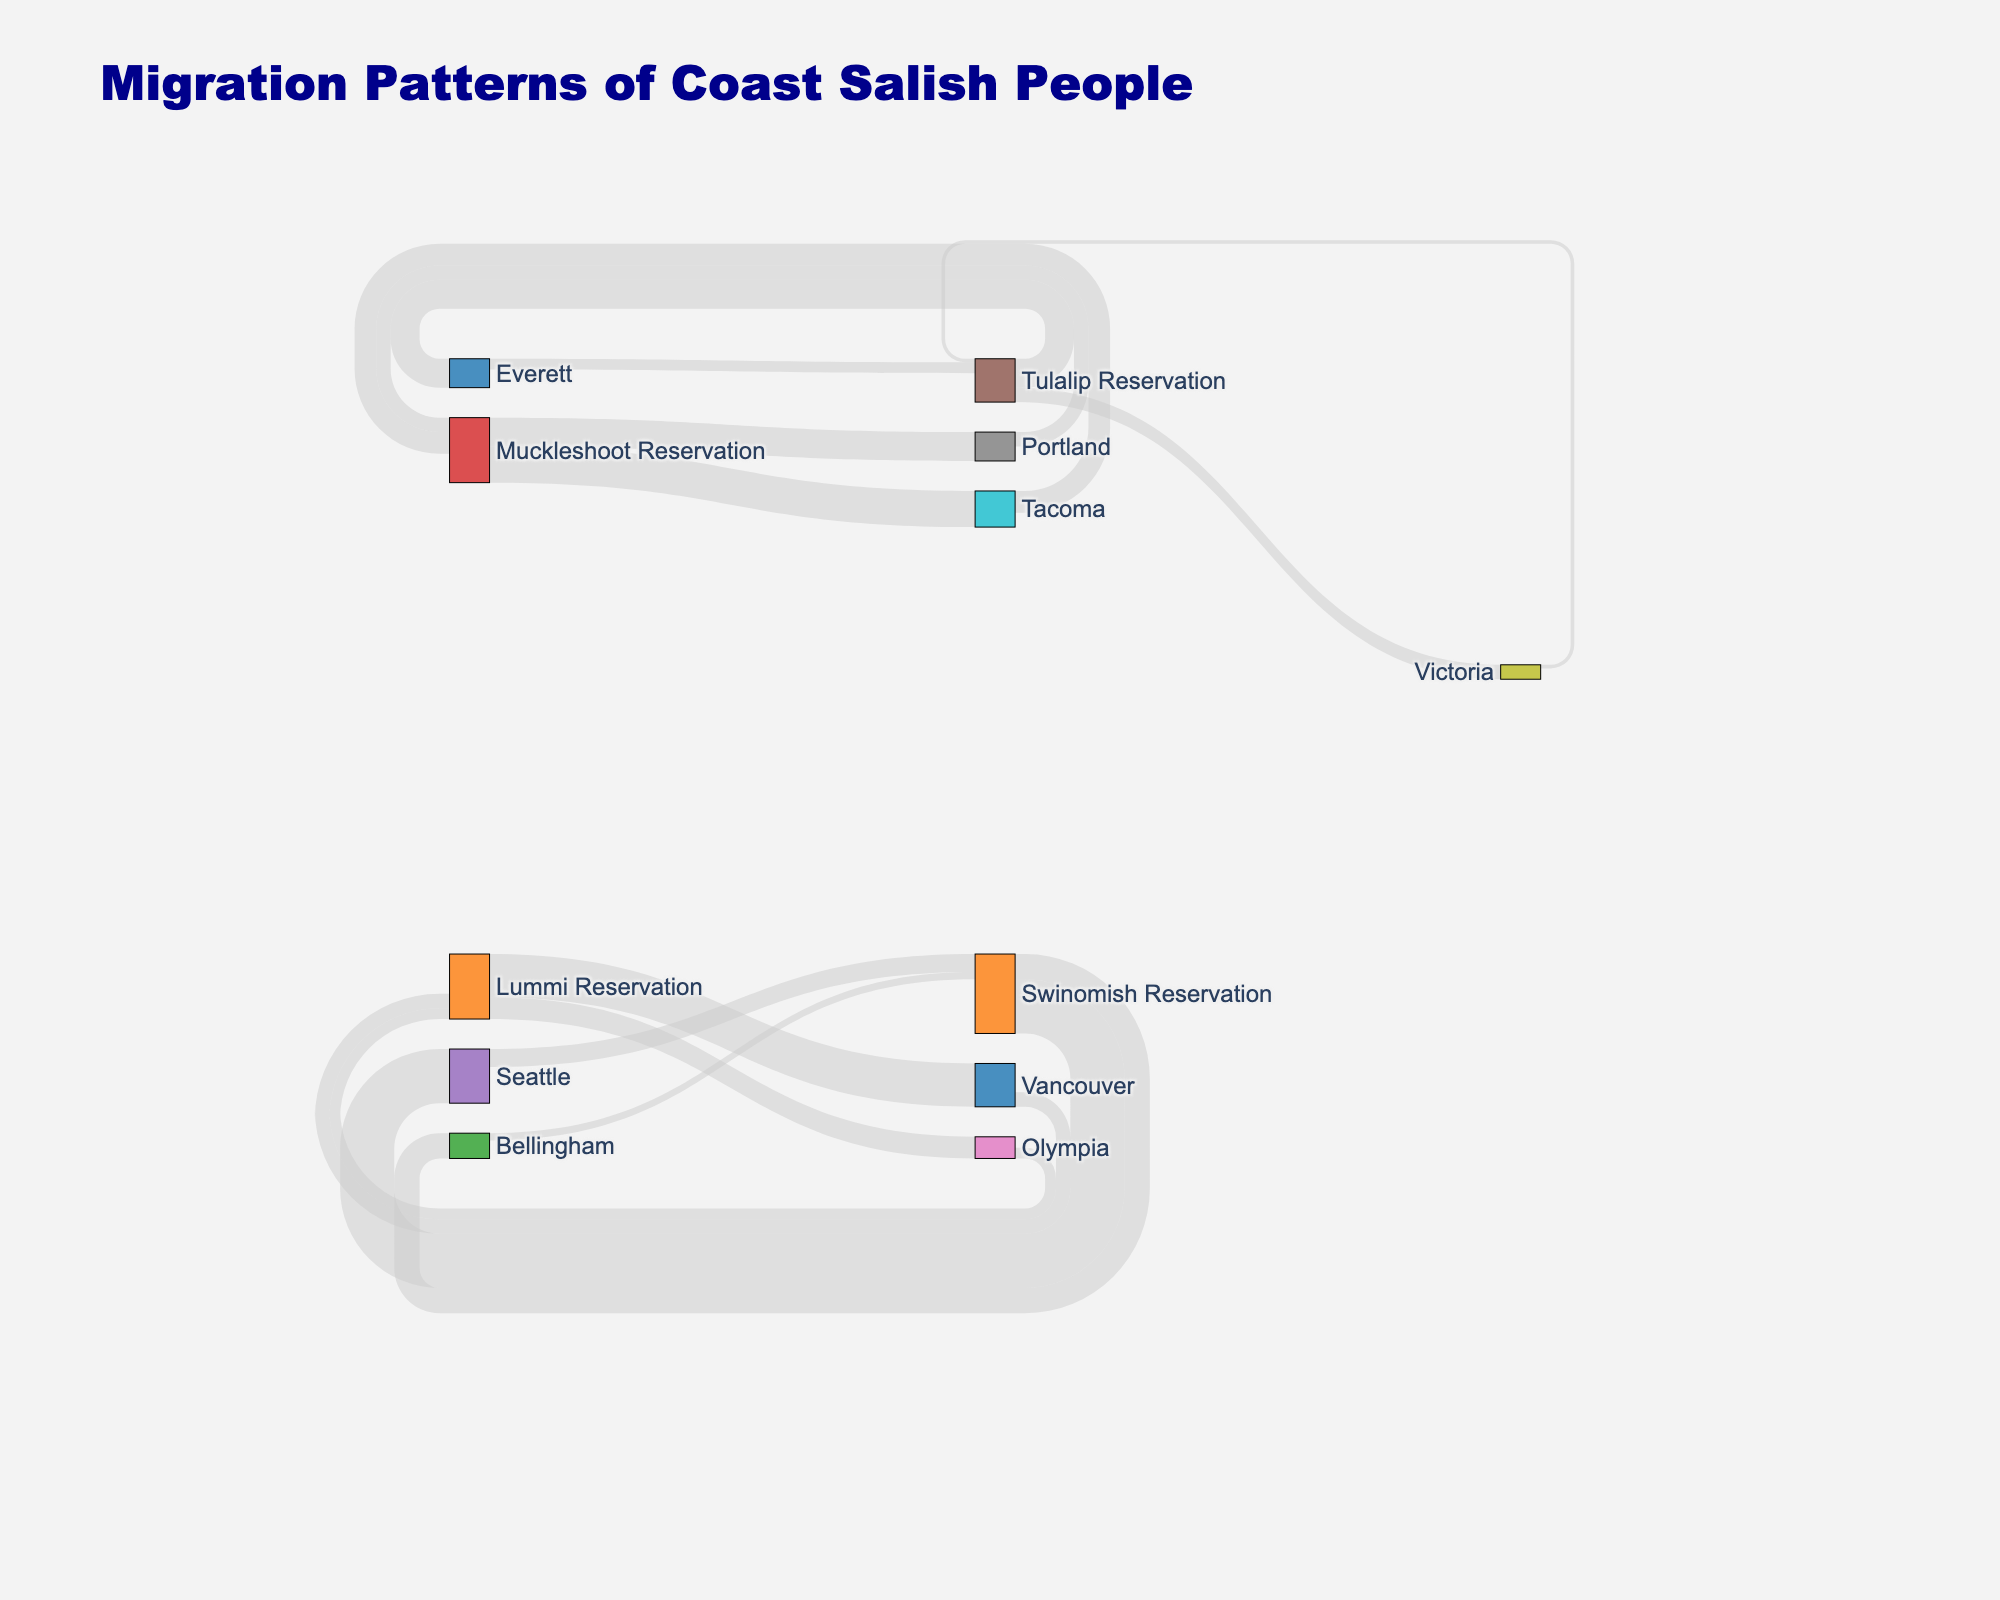What is the title of the Sankey diagram? The title of the Sankey diagram is located at the top of the figure. This title provides a summary of the diagram's focus. In this case, it is "Migration Patterns of Coast Salish People".
Answer: Migration Patterns of Coast Salish People Which reservation has the largest number of people moving to urban areas? Look at the different links emanating from the reservations to various urban areas. Identify the reservation associated with the highest value. Here, Swinomish Reservation to Seattle has the largest value of 1500.
Answer: Swinomish Reservation What is the total number of people documented in the migrations from Seattle to the reservations? Check the links that originate from Seattle and sum up their values. From Seattle to Swinomish Reservation, the value is 500.
Answer: 500 How many people migrated from Muckleshoot Reservation to urban areas in total? Identify and sum the values of the links originating from Muckleshoot Reservation to different urban areas. These are Tacoma (1000) and Portland (800). The sum is 1000 + 800 = 1800.
Answer: 1800 Which urban area has the most movements from reservations? Compare the incoming values to each urban area. Seattle has the highest incoming value, stemming from Swinomish Reservation with 1500 people.
Answer: Seattle What is the total movement involving the Lummi Reservation (both incoming and outgoing)? Sum the values of all flows connected to Lummi Reservation. Outgoing: Vancouver (1200) and Olympia (600); Incoming: Vancouver (400), Olympia (300). The total is 1200 + 600 + 400 + 300 = 2500.
Answer: 2500 Which link represents the smallest migration flow and what is its value? Locate the smallest value among all the links in the diagram. The link from Victoria to Tulalip Reservation has the smallest value of 100.
Answer: Victoria to Tulalip Reservation, 100 What is the color used to represent nodes? The nodes are represented with various colors, predominantly different shades of blue, orange, green, red, purple, brown, pink, gray, yellow, and light blue. This can be seen in the sections marked for different reservations.
Answer: Various shades of blue, orange, green, red, purple, brown, pink, gray, yellow, light blue How many total types of location nodes are there in the diagram? Count all the unique nodes in the diagram, which represent reservations and urban areas.
Answer: 16 Which reservation has the most balanced migration in and out, and what are the respective values? Balance is found by comparing the incoming and outgoing values of each reservation. The Tulalip Reservation has incoming (300 + 100 = 400) and outgoing (800 + 400 = 1200). Swinomish Reservation: Incoming (500 + 200 = 700), Outgoing (1500 + 700 = 2200). Tulalip's values are 400 in and 1200 out, which is more balanced than others.
Answer: Tulalip Reservation, 400 inbound and 1200 outbound 